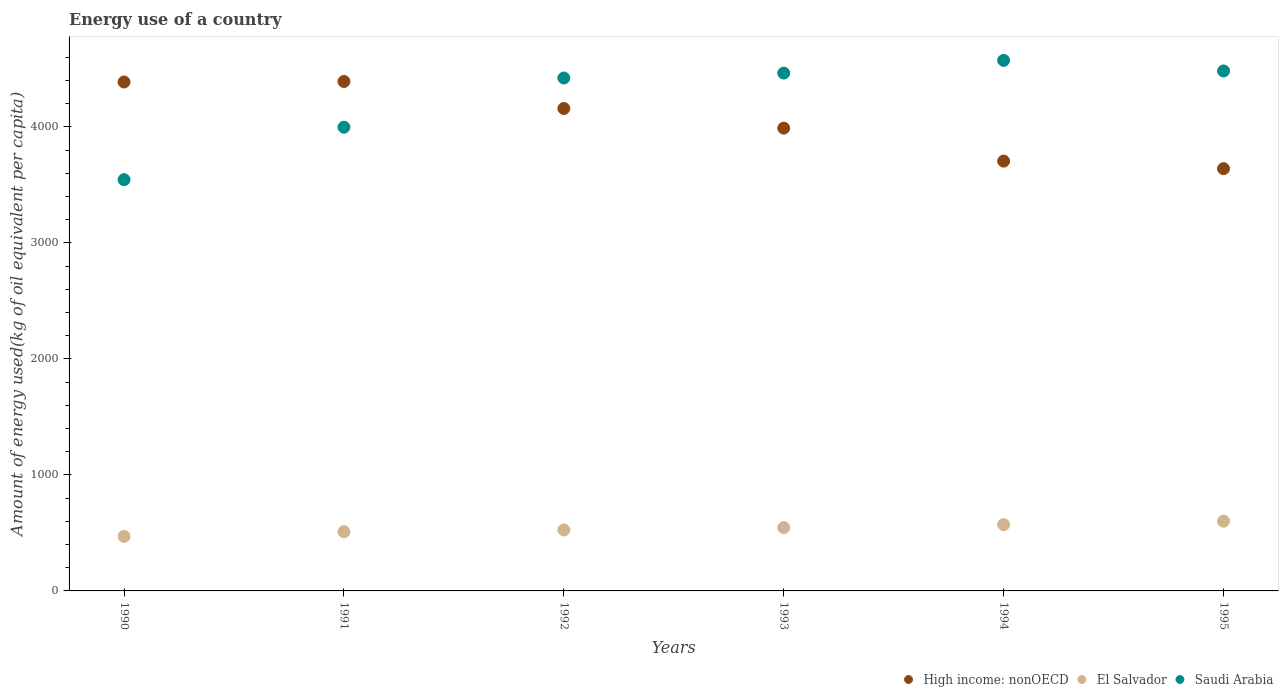How many different coloured dotlines are there?
Provide a succinct answer. 3. Is the number of dotlines equal to the number of legend labels?
Provide a succinct answer. Yes. What is the amount of energy used in in High income: nonOECD in 1991?
Your response must be concise. 4391.51. Across all years, what is the maximum amount of energy used in in High income: nonOECD?
Your response must be concise. 4391.51. Across all years, what is the minimum amount of energy used in in Saudi Arabia?
Ensure brevity in your answer.  3545.24. In which year was the amount of energy used in in Saudi Arabia maximum?
Provide a short and direct response. 1994. What is the total amount of energy used in in El Salvador in the graph?
Give a very brief answer. 3224.03. What is the difference between the amount of energy used in in El Salvador in 1990 and that in 1995?
Your response must be concise. -130.95. What is the difference between the amount of energy used in in High income: nonOECD in 1993 and the amount of energy used in in Saudi Arabia in 1992?
Keep it short and to the point. -432.37. What is the average amount of energy used in in High income: nonOECD per year?
Your response must be concise. 4045.3. In the year 1995, what is the difference between the amount of energy used in in El Salvador and amount of energy used in in Saudi Arabia?
Keep it short and to the point. -3881.29. What is the ratio of the amount of energy used in in Saudi Arabia in 1990 to that in 1993?
Give a very brief answer. 0.79. What is the difference between the highest and the second highest amount of energy used in in High income: nonOECD?
Keep it short and to the point. 4.27. What is the difference between the highest and the lowest amount of energy used in in El Salvador?
Your answer should be compact. 130.95. Is the sum of the amount of energy used in in High income: nonOECD in 1992 and 1995 greater than the maximum amount of energy used in in Saudi Arabia across all years?
Offer a terse response. Yes. Is it the case that in every year, the sum of the amount of energy used in in Saudi Arabia and amount of energy used in in High income: nonOECD  is greater than the amount of energy used in in El Salvador?
Keep it short and to the point. Yes. Does the amount of energy used in in High income: nonOECD monotonically increase over the years?
Provide a short and direct response. No. Is the amount of energy used in in El Salvador strictly less than the amount of energy used in in High income: nonOECD over the years?
Keep it short and to the point. Yes. How many years are there in the graph?
Offer a very short reply. 6. What is the difference between two consecutive major ticks on the Y-axis?
Provide a succinct answer. 1000. Does the graph contain grids?
Offer a very short reply. No. How many legend labels are there?
Give a very brief answer. 3. What is the title of the graph?
Offer a terse response. Energy use of a country. What is the label or title of the Y-axis?
Your response must be concise. Amount of energy used(kg of oil equivalent per capita). What is the Amount of energy used(kg of oil equivalent per capita) in High income: nonOECD in 1990?
Your response must be concise. 4387.24. What is the Amount of energy used(kg of oil equivalent per capita) of El Salvador in 1990?
Your response must be concise. 470.04. What is the Amount of energy used(kg of oil equivalent per capita) in Saudi Arabia in 1990?
Your answer should be compact. 3545.24. What is the Amount of energy used(kg of oil equivalent per capita) of High income: nonOECD in 1991?
Offer a very short reply. 4391.51. What is the Amount of energy used(kg of oil equivalent per capita) of El Salvador in 1991?
Ensure brevity in your answer.  510.06. What is the Amount of energy used(kg of oil equivalent per capita) in Saudi Arabia in 1991?
Ensure brevity in your answer.  3997.62. What is the Amount of energy used(kg of oil equivalent per capita) of High income: nonOECD in 1992?
Offer a very short reply. 4158.79. What is the Amount of energy used(kg of oil equivalent per capita) of El Salvador in 1992?
Offer a terse response. 525.45. What is the Amount of energy used(kg of oil equivalent per capita) in Saudi Arabia in 1992?
Provide a short and direct response. 4421.51. What is the Amount of energy used(kg of oil equivalent per capita) in High income: nonOECD in 1993?
Your response must be concise. 3989.13. What is the Amount of energy used(kg of oil equivalent per capita) of El Salvador in 1993?
Provide a succinct answer. 546.06. What is the Amount of energy used(kg of oil equivalent per capita) of Saudi Arabia in 1993?
Your answer should be very brief. 4463.81. What is the Amount of energy used(kg of oil equivalent per capita) of High income: nonOECD in 1994?
Your response must be concise. 3705.16. What is the Amount of energy used(kg of oil equivalent per capita) of El Salvador in 1994?
Make the answer very short. 571.42. What is the Amount of energy used(kg of oil equivalent per capita) of Saudi Arabia in 1994?
Make the answer very short. 4573.44. What is the Amount of energy used(kg of oil equivalent per capita) in High income: nonOECD in 1995?
Keep it short and to the point. 3639.98. What is the Amount of energy used(kg of oil equivalent per capita) of El Salvador in 1995?
Offer a terse response. 601. What is the Amount of energy used(kg of oil equivalent per capita) of Saudi Arabia in 1995?
Give a very brief answer. 4482.28. Across all years, what is the maximum Amount of energy used(kg of oil equivalent per capita) of High income: nonOECD?
Provide a short and direct response. 4391.51. Across all years, what is the maximum Amount of energy used(kg of oil equivalent per capita) in El Salvador?
Make the answer very short. 601. Across all years, what is the maximum Amount of energy used(kg of oil equivalent per capita) in Saudi Arabia?
Your answer should be very brief. 4573.44. Across all years, what is the minimum Amount of energy used(kg of oil equivalent per capita) of High income: nonOECD?
Your answer should be very brief. 3639.98. Across all years, what is the minimum Amount of energy used(kg of oil equivalent per capita) of El Salvador?
Ensure brevity in your answer.  470.04. Across all years, what is the minimum Amount of energy used(kg of oil equivalent per capita) of Saudi Arabia?
Provide a short and direct response. 3545.24. What is the total Amount of energy used(kg of oil equivalent per capita) in High income: nonOECD in the graph?
Offer a terse response. 2.43e+04. What is the total Amount of energy used(kg of oil equivalent per capita) in El Salvador in the graph?
Offer a very short reply. 3224.03. What is the total Amount of energy used(kg of oil equivalent per capita) of Saudi Arabia in the graph?
Ensure brevity in your answer.  2.55e+04. What is the difference between the Amount of energy used(kg of oil equivalent per capita) in High income: nonOECD in 1990 and that in 1991?
Keep it short and to the point. -4.27. What is the difference between the Amount of energy used(kg of oil equivalent per capita) in El Salvador in 1990 and that in 1991?
Your answer should be compact. -40.02. What is the difference between the Amount of energy used(kg of oil equivalent per capita) in Saudi Arabia in 1990 and that in 1991?
Keep it short and to the point. -452.37. What is the difference between the Amount of energy used(kg of oil equivalent per capita) of High income: nonOECD in 1990 and that in 1992?
Keep it short and to the point. 228.45. What is the difference between the Amount of energy used(kg of oil equivalent per capita) in El Salvador in 1990 and that in 1992?
Your answer should be compact. -55.41. What is the difference between the Amount of energy used(kg of oil equivalent per capita) in Saudi Arabia in 1990 and that in 1992?
Ensure brevity in your answer.  -876.27. What is the difference between the Amount of energy used(kg of oil equivalent per capita) in High income: nonOECD in 1990 and that in 1993?
Your response must be concise. 398.11. What is the difference between the Amount of energy used(kg of oil equivalent per capita) of El Salvador in 1990 and that in 1993?
Ensure brevity in your answer.  -76.01. What is the difference between the Amount of energy used(kg of oil equivalent per capita) in Saudi Arabia in 1990 and that in 1993?
Offer a terse response. -918.57. What is the difference between the Amount of energy used(kg of oil equivalent per capita) of High income: nonOECD in 1990 and that in 1994?
Your answer should be compact. 682.08. What is the difference between the Amount of energy used(kg of oil equivalent per capita) of El Salvador in 1990 and that in 1994?
Provide a succinct answer. -101.37. What is the difference between the Amount of energy used(kg of oil equivalent per capita) in Saudi Arabia in 1990 and that in 1994?
Offer a terse response. -1028.2. What is the difference between the Amount of energy used(kg of oil equivalent per capita) in High income: nonOECD in 1990 and that in 1995?
Provide a short and direct response. 747.26. What is the difference between the Amount of energy used(kg of oil equivalent per capita) in El Salvador in 1990 and that in 1995?
Your answer should be compact. -130.95. What is the difference between the Amount of energy used(kg of oil equivalent per capita) of Saudi Arabia in 1990 and that in 1995?
Make the answer very short. -937.04. What is the difference between the Amount of energy used(kg of oil equivalent per capita) of High income: nonOECD in 1991 and that in 1992?
Offer a terse response. 232.72. What is the difference between the Amount of energy used(kg of oil equivalent per capita) in El Salvador in 1991 and that in 1992?
Make the answer very short. -15.39. What is the difference between the Amount of energy used(kg of oil equivalent per capita) of Saudi Arabia in 1991 and that in 1992?
Provide a short and direct response. -423.89. What is the difference between the Amount of energy used(kg of oil equivalent per capita) in High income: nonOECD in 1991 and that in 1993?
Provide a succinct answer. 402.38. What is the difference between the Amount of energy used(kg of oil equivalent per capita) in El Salvador in 1991 and that in 1993?
Give a very brief answer. -35.99. What is the difference between the Amount of energy used(kg of oil equivalent per capita) in Saudi Arabia in 1991 and that in 1993?
Your answer should be very brief. -466.19. What is the difference between the Amount of energy used(kg of oil equivalent per capita) in High income: nonOECD in 1991 and that in 1994?
Your response must be concise. 686.35. What is the difference between the Amount of energy used(kg of oil equivalent per capita) in El Salvador in 1991 and that in 1994?
Give a very brief answer. -61.35. What is the difference between the Amount of energy used(kg of oil equivalent per capita) in Saudi Arabia in 1991 and that in 1994?
Your answer should be very brief. -575.83. What is the difference between the Amount of energy used(kg of oil equivalent per capita) in High income: nonOECD in 1991 and that in 1995?
Offer a very short reply. 751.53. What is the difference between the Amount of energy used(kg of oil equivalent per capita) of El Salvador in 1991 and that in 1995?
Give a very brief answer. -90.94. What is the difference between the Amount of energy used(kg of oil equivalent per capita) in Saudi Arabia in 1991 and that in 1995?
Give a very brief answer. -484.67. What is the difference between the Amount of energy used(kg of oil equivalent per capita) of High income: nonOECD in 1992 and that in 1993?
Ensure brevity in your answer.  169.66. What is the difference between the Amount of energy used(kg of oil equivalent per capita) of El Salvador in 1992 and that in 1993?
Keep it short and to the point. -20.6. What is the difference between the Amount of energy used(kg of oil equivalent per capita) in Saudi Arabia in 1992 and that in 1993?
Give a very brief answer. -42.3. What is the difference between the Amount of energy used(kg of oil equivalent per capita) in High income: nonOECD in 1992 and that in 1994?
Provide a succinct answer. 453.63. What is the difference between the Amount of energy used(kg of oil equivalent per capita) of El Salvador in 1992 and that in 1994?
Provide a succinct answer. -45.96. What is the difference between the Amount of energy used(kg of oil equivalent per capita) of Saudi Arabia in 1992 and that in 1994?
Keep it short and to the point. -151.94. What is the difference between the Amount of energy used(kg of oil equivalent per capita) of High income: nonOECD in 1992 and that in 1995?
Provide a succinct answer. 518.81. What is the difference between the Amount of energy used(kg of oil equivalent per capita) in El Salvador in 1992 and that in 1995?
Your response must be concise. -75.54. What is the difference between the Amount of energy used(kg of oil equivalent per capita) in Saudi Arabia in 1992 and that in 1995?
Your answer should be very brief. -60.78. What is the difference between the Amount of energy used(kg of oil equivalent per capita) of High income: nonOECD in 1993 and that in 1994?
Your answer should be compact. 283.97. What is the difference between the Amount of energy used(kg of oil equivalent per capita) of El Salvador in 1993 and that in 1994?
Make the answer very short. -25.36. What is the difference between the Amount of energy used(kg of oil equivalent per capita) in Saudi Arabia in 1993 and that in 1994?
Keep it short and to the point. -109.64. What is the difference between the Amount of energy used(kg of oil equivalent per capita) in High income: nonOECD in 1993 and that in 1995?
Keep it short and to the point. 349.15. What is the difference between the Amount of energy used(kg of oil equivalent per capita) of El Salvador in 1993 and that in 1995?
Provide a succinct answer. -54.94. What is the difference between the Amount of energy used(kg of oil equivalent per capita) in Saudi Arabia in 1993 and that in 1995?
Ensure brevity in your answer.  -18.48. What is the difference between the Amount of energy used(kg of oil equivalent per capita) in High income: nonOECD in 1994 and that in 1995?
Your response must be concise. 65.18. What is the difference between the Amount of energy used(kg of oil equivalent per capita) in El Salvador in 1994 and that in 1995?
Provide a succinct answer. -29.58. What is the difference between the Amount of energy used(kg of oil equivalent per capita) of Saudi Arabia in 1994 and that in 1995?
Your response must be concise. 91.16. What is the difference between the Amount of energy used(kg of oil equivalent per capita) of High income: nonOECD in 1990 and the Amount of energy used(kg of oil equivalent per capita) of El Salvador in 1991?
Make the answer very short. 3877.18. What is the difference between the Amount of energy used(kg of oil equivalent per capita) of High income: nonOECD in 1990 and the Amount of energy used(kg of oil equivalent per capita) of Saudi Arabia in 1991?
Keep it short and to the point. 389.62. What is the difference between the Amount of energy used(kg of oil equivalent per capita) in El Salvador in 1990 and the Amount of energy used(kg of oil equivalent per capita) in Saudi Arabia in 1991?
Ensure brevity in your answer.  -3527.57. What is the difference between the Amount of energy used(kg of oil equivalent per capita) in High income: nonOECD in 1990 and the Amount of energy used(kg of oil equivalent per capita) in El Salvador in 1992?
Offer a terse response. 3861.79. What is the difference between the Amount of energy used(kg of oil equivalent per capita) of High income: nonOECD in 1990 and the Amount of energy used(kg of oil equivalent per capita) of Saudi Arabia in 1992?
Your answer should be very brief. -34.27. What is the difference between the Amount of energy used(kg of oil equivalent per capita) of El Salvador in 1990 and the Amount of energy used(kg of oil equivalent per capita) of Saudi Arabia in 1992?
Your answer should be compact. -3951.46. What is the difference between the Amount of energy used(kg of oil equivalent per capita) of High income: nonOECD in 1990 and the Amount of energy used(kg of oil equivalent per capita) of El Salvador in 1993?
Your answer should be compact. 3841.18. What is the difference between the Amount of energy used(kg of oil equivalent per capita) of High income: nonOECD in 1990 and the Amount of energy used(kg of oil equivalent per capita) of Saudi Arabia in 1993?
Your response must be concise. -76.57. What is the difference between the Amount of energy used(kg of oil equivalent per capita) of El Salvador in 1990 and the Amount of energy used(kg of oil equivalent per capita) of Saudi Arabia in 1993?
Your answer should be very brief. -3993.76. What is the difference between the Amount of energy used(kg of oil equivalent per capita) of High income: nonOECD in 1990 and the Amount of energy used(kg of oil equivalent per capita) of El Salvador in 1994?
Offer a terse response. 3815.82. What is the difference between the Amount of energy used(kg of oil equivalent per capita) in High income: nonOECD in 1990 and the Amount of energy used(kg of oil equivalent per capita) in Saudi Arabia in 1994?
Make the answer very short. -186.2. What is the difference between the Amount of energy used(kg of oil equivalent per capita) in El Salvador in 1990 and the Amount of energy used(kg of oil equivalent per capita) in Saudi Arabia in 1994?
Keep it short and to the point. -4103.4. What is the difference between the Amount of energy used(kg of oil equivalent per capita) of High income: nonOECD in 1990 and the Amount of energy used(kg of oil equivalent per capita) of El Salvador in 1995?
Ensure brevity in your answer.  3786.24. What is the difference between the Amount of energy used(kg of oil equivalent per capita) in High income: nonOECD in 1990 and the Amount of energy used(kg of oil equivalent per capita) in Saudi Arabia in 1995?
Provide a short and direct response. -95.04. What is the difference between the Amount of energy used(kg of oil equivalent per capita) in El Salvador in 1990 and the Amount of energy used(kg of oil equivalent per capita) in Saudi Arabia in 1995?
Make the answer very short. -4012.24. What is the difference between the Amount of energy used(kg of oil equivalent per capita) in High income: nonOECD in 1991 and the Amount of energy used(kg of oil equivalent per capita) in El Salvador in 1992?
Your answer should be very brief. 3866.06. What is the difference between the Amount of energy used(kg of oil equivalent per capita) in High income: nonOECD in 1991 and the Amount of energy used(kg of oil equivalent per capita) in Saudi Arabia in 1992?
Offer a terse response. -30. What is the difference between the Amount of energy used(kg of oil equivalent per capita) of El Salvador in 1991 and the Amount of energy used(kg of oil equivalent per capita) of Saudi Arabia in 1992?
Provide a succinct answer. -3911.45. What is the difference between the Amount of energy used(kg of oil equivalent per capita) in High income: nonOECD in 1991 and the Amount of energy used(kg of oil equivalent per capita) in El Salvador in 1993?
Your answer should be compact. 3845.45. What is the difference between the Amount of energy used(kg of oil equivalent per capita) of High income: nonOECD in 1991 and the Amount of energy used(kg of oil equivalent per capita) of Saudi Arabia in 1993?
Keep it short and to the point. -72.3. What is the difference between the Amount of energy used(kg of oil equivalent per capita) of El Salvador in 1991 and the Amount of energy used(kg of oil equivalent per capita) of Saudi Arabia in 1993?
Your answer should be compact. -3953.75. What is the difference between the Amount of energy used(kg of oil equivalent per capita) of High income: nonOECD in 1991 and the Amount of energy used(kg of oil equivalent per capita) of El Salvador in 1994?
Your answer should be very brief. 3820.09. What is the difference between the Amount of energy used(kg of oil equivalent per capita) of High income: nonOECD in 1991 and the Amount of energy used(kg of oil equivalent per capita) of Saudi Arabia in 1994?
Ensure brevity in your answer.  -181.93. What is the difference between the Amount of energy used(kg of oil equivalent per capita) in El Salvador in 1991 and the Amount of energy used(kg of oil equivalent per capita) in Saudi Arabia in 1994?
Your answer should be very brief. -4063.38. What is the difference between the Amount of energy used(kg of oil equivalent per capita) in High income: nonOECD in 1991 and the Amount of energy used(kg of oil equivalent per capita) in El Salvador in 1995?
Your response must be concise. 3790.51. What is the difference between the Amount of energy used(kg of oil equivalent per capita) in High income: nonOECD in 1991 and the Amount of energy used(kg of oil equivalent per capita) in Saudi Arabia in 1995?
Keep it short and to the point. -90.77. What is the difference between the Amount of energy used(kg of oil equivalent per capita) of El Salvador in 1991 and the Amount of energy used(kg of oil equivalent per capita) of Saudi Arabia in 1995?
Keep it short and to the point. -3972.22. What is the difference between the Amount of energy used(kg of oil equivalent per capita) of High income: nonOECD in 1992 and the Amount of energy used(kg of oil equivalent per capita) of El Salvador in 1993?
Make the answer very short. 3612.73. What is the difference between the Amount of energy used(kg of oil equivalent per capita) in High income: nonOECD in 1992 and the Amount of energy used(kg of oil equivalent per capita) in Saudi Arabia in 1993?
Provide a short and direct response. -305.02. What is the difference between the Amount of energy used(kg of oil equivalent per capita) in El Salvador in 1992 and the Amount of energy used(kg of oil equivalent per capita) in Saudi Arabia in 1993?
Offer a terse response. -3938.35. What is the difference between the Amount of energy used(kg of oil equivalent per capita) in High income: nonOECD in 1992 and the Amount of energy used(kg of oil equivalent per capita) in El Salvador in 1994?
Your answer should be very brief. 3587.37. What is the difference between the Amount of energy used(kg of oil equivalent per capita) of High income: nonOECD in 1992 and the Amount of energy used(kg of oil equivalent per capita) of Saudi Arabia in 1994?
Offer a terse response. -414.65. What is the difference between the Amount of energy used(kg of oil equivalent per capita) of El Salvador in 1992 and the Amount of energy used(kg of oil equivalent per capita) of Saudi Arabia in 1994?
Your answer should be compact. -4047.99. What is the difference between the Amount of energy used(kg of oil equivalent per capita) in High income: nonOECD in 1992 and the Amount of energy used(kg of oil equivalent per capita) in El Salvador in 1995?
Give a very brief answer. 3557.79. What is the difference between the Amount of energy used(kg of oil equivalent per capita) of High income: nonOECD in 1992 and the Amount of energy used(kg of oil equivalent per capita) of Saudi Arabia in 1995?
Make the answer very short. -323.49. What is the difference between the Amount of energy used(kg of oil equivalent per capita) of El Salvador in 1992 and the Amount of energy used(kg of oil equivalent per capita) of Saudi Arabia in 1995?
Make the answer very short. -3956.83. What is the difference between the Amount of energy used(kg of oil equivalent per capita) in High income: nonOECD in 1993 and the Amount of energy used(kg of oil equivalent per capita) in El Salvador in 1994?
Provide a short and direct response. 3417.72. What is the difference between the Amount of energy used(kg of oil equivalent per capita) in High income: nonOECD in 1993 and the Amount of energy used(kg of oil equivalent per capita) in Saudi Arabia in 1994?
Ensure brevity in your answer.  -584.31. What is the difference between the Amount of energy used(kg of oil equivalent per capita) in El Salvador in 1993 and the Amount of energy used(kg of oil equivalent per capita) in Saudi Arabia in 1994?
Offer a terse response. -4027.39. What is the difference between the Amount of energy used(kg of oil equivalent per capita) of High income: nonOECD in 1993 and the Amount of energy used(kg of oil equivalent per capita) of El Salvador in 1995?
Offer a very short reply. 3388.14. What is the difference between the Amount of energy used(kg of oil equivalent per capita) in High income: nonOECD in 1993 and the Amount of energy used(kg of oil equivalent per capita) in Saudi Arabia in 1995?
Offer a very short reply. -493.15. What is the difference between the Amount of energy used(kg of oil equivalent per capita) of El Salvador in 1993 and the Amount of energy used(kg of oil equivalent per capita) of Saudi Arabia in 1995?
Ensure brevity in your answer.  -3936.23. What is the difference between the Amount of energy used(kg of oil equivalent per capita) in High income: nonOECD in 1994 and the Amount of energy used(kg of oil equivalent per capita) in El Salvador in 1995?
Provide a short and direct response. 3104.16. What is the difference between the Amount of energy used(kg of oil equivalent per capita) in High income: nonOECD in 1994 and the Amount of energy used(kg of oil equivalent per capita) in Saudi Arabia in 1995?
Offer a very short reply. -777.12. What is the difference between the Amount of energy used(kg of oil equivalent per capita) of El Salvador in 1994 and the Amount of energy used(kg of oil equivalent per capita) of Saudi Arabia in 1995?
Offer a terse response. -3910.87. What is the average Amount of energy used(kg of oil equivalent per capita) of High income: nonOECD per year?
Your response must be concise. 4045.3. What is the average Amount of energy used(kg of oil equivalent per capita) in El Salvador per year?
Keep it short and to the point. 537.34. What is the average Amount of energy used(kg of oil equivalent per capita) in Saudi Arabia per year?
Offer a terse response. 4247.32. In the year 1990, what is the difference between the Amount of energy used(kg of oil equivalent per capita) in High income: nonOECD and Amount of energy used(kg of oil equivalent per capita) in El Salvador?
Your answer should be compact. 3917.2. In the year 1990, what is the difference between the Amount of energy used(kg of oil equivalent per capita) of High income: nonOECD and Amount of energy used(kg of oil equivalent per capita) of Saudi Arabia?
Provide a short and direct response. 842. In the year 1990, what is the difference between the Amount of energy used(kg of oil equivalent per capita) in El Salvador and Amount of energy used(kg of oil equivalent per capita) in Saudi Arabia?
Your answer should be compact. -3075.2. In the year 1991, what is the difference between the Amount of energy used(kg of oil equivalent per capita) of High income: nonOECD and Amount of energy used(kg of oil equivalent per capita) of El Salvador?
Keep it short and to the point. 3881.45. In the year 1991, what is the difference between the Amount of energy used(kg of oil equivalent per capita) in High income: nonOECD and Amount of energy used(kg of oil equivalent per capita) in Saudi Arabia?
Ensure brevity in your answer.  393.89. In the year 1991, what is the difference between the Amount of energy used(kg of oil equivalent per capita) in El Salvador and Amount of energy used(kg of oil equivalent per capita) in Saudi Arabia?
Give a very brief answer. -3487.55. In the year 1992, what is the difference between the Amount of energy used(kg of oil equivalent per capita) of High income: nonOECD and Amount of energy used(kg of oil equivalent per capita) of El Salvador?
Keep it short and to the point. 3633.34. In the year 1992, what is the difference between the Amount of energy used(kg of oil equivalent per capita) in High income: nonOECD and Amount of energy used(kg of oil equivalent per capita) in Saudi Arabia?
Make the answer very short. -262.72. In the year 1992, what is the difference between the Amount of energy used(kg of oil equivalent per capita) in El Salvador and Amount of energy used(kg of oil equivalent per capita) in Saudi Arabia?
Offer a terse response. -3896.05. In the year 1993, what is the difference between the Amount of energy used(kg of oil equivalent per capita) of High income: nonOECD and Amount of energy used(kg of oil equivalent per capita) of El Salvador?
Make the answer very short. 3443.08. In the year 1993, what is the difference between the Amount of energy used(kg of oil equivalent per capita) in High income: nonOECD and Amount of energy used(kg of oil equivalent per capita) in Saudi Arabia?
Ensure brevity in your answer.  -474.67. In the year 1993, what is the difference between the Amount of energy used(kg of oil equivalent per capita) of El Salvador and Amount of energy used(kg of oil equivalent per capita) of Saudi Arabia?
Your response must be concise. -3917.75. In the year 1994, what is the difference between the Amount of energy used(kg of oil equivalent per capita) of High income: nonOECD and Amount of energy used(kg of oil equivalent per capita) of El Salvador?
Provide a succinct answer. 3133.75. In the year 1994, what is the difference between the Amount of energy used(kg of oil equivalent per capita) in High income: nonOECD and Amount of energy used(kg of oil equivalent per capita) in Saudi Arabia?
Keep it short and to the point. -868.28. In the year 1994, what is the difference between the Amount of energy used(kg of oil equivalent per capita) of El Salvador and Amount of energy used(kg of oil equivalent per capita) of Saudi Arabia?
Ensure brevity in your answer.  -4002.03. In the year 1995, what is the difference between the Amount of energy used(kg of oil equivalent per capita) of High income: nonOECD and Amount of energy used(kg of oil equivalent per capita) of El Salvador?
Your answer should be compact. 3038.99. In the year 1995, what is the difference between the Amount of energy used(kg of oil equivalent per capita) of High income: nonOECD and Amount of energy used(kg of oil equivalent per capita) of Saudi Arabia?
Your answer should be compact. -842.3. In the year 1995, what is the difference between the Amount of energy used(kg of oil equivalent per capita) of El Salvador and Amount of energy used(kg of oil equivalent per capita) of Saudi Arabia?
Your response must be concise. -3881.29. What is the ratio of the Amount of energy used(kg of oil equivalent per capita) in High income: nonOECD in 1990 to that in 1991?
Your answer should be very brief. 1. What is the ratio of the Amount of energy used(kg of oil equivalent per capita) in El Salvador in 1990 to that in 1991?
Offer a very short reply. 0.92. What is the ratio of the Amount of energy used(kg of oil equivalent per capita) of Saudi Arabia in 1990 to that in 1991?
Your response must be concise. 0.89. What is the ratio of the Amount of energy used(kg of oil equivalent per capita) of High income: nonOECD in 1990 to that in 1992?
Your answer should be compact. 1.05. What is the ratio of the Amount of energy used(kg of oil equivalent per capita) of El Salvador in 1990 to that in 1992?
Ensure brevity in your answer.  0.89. What is the ratio of the Amount of energy used(kg of oil equivalent per capita) of Saudi Arabia in 1990 to that in 1992?
Ensure brevity in your answer.  0.8. What is the ratio of the Amount of energy used(kg of oil equivalent per capita) of High income: nonOECD in 1990 to that in 1993?
Give a very brief answer. 1.1. What is the ratio of the Amount of energy used(kg of oil equivalent per capita) in El Salvador in 1990 to that in 1993?
Provide a short and direct response. 0.86. What is the ratio of the Amount of energy used(kg of oil equivalent per capita) of Saudi Arabia in 1990 to that in 1993?
Give a very brief answer. 0.79. What is the ratio of the Amount of energy used(kg of oil equivalent per capita) in High income: nonOECD in 1990 to that in 1994?
Your answer should be compact. 1.18. What is the ratio of the Amount of energy used(kg of oil equivalent per capita) of El Salvador in 1990 to that in 1994?
Provide a succinct answer. 0.82. What is the ratio of the Amount of energy used(kg of oil equivalent per capita) of Saudi Arabia in 1990 to that in 1994?
Provide a short and direct response. 0.78. What is the ratio of the Amount of energy used(kg of oil equivalent per capita) in High income: nonOECD in 1990 to that in 1995?
Your answer should be very brief. 1.21. What is the ratio of the Amount of energy used(kg of oil equivalent per capita) in El Salvador in 1990 to that in 1995?
Keep it short and to the point. 0.78. What is the ratio of the Amount of energy used(kg of oil equivalent per capita) in Saudi Arabia in 1990 to that in 1995?
Offer a very short reply. 0.79. What is the ratio of the Amount of energy used(kg of oil equivalent per capita) in High income: nonOECD in 1991 to that in 1992?
Provide a succinct answer. 1.06. What is the ratio of the Amount of energy used(kg of oil equivalent per capita) of El Salvador in 1991 to that in 1992?
Your answer should be very brief. 0.97. What is the ratio of the Amount of energy used(kg of oil equivalent per capita) of Saudi Arabia in 1991 to that in 1992?
Keep it short and to the point. 0.9. What is the ratio of the Amount of energy used(kg of oil equivalent per capita) of High income: nonOECD in 1991 to that in 1993?
Your answer should be compact. 1.1. What is the ratio of the Amount of energy used(kg of oil equivalent per capita) in El Salvador in 1991 to that in 1993?
Provide a succinct answer. 0.93. What is the ratio of the Amount of energy used(kg of oil equivalent per capita) of Saudi Arabia in 1991 to that in 1993?
Ensure brevity in your answer.  0.9. What is the ratio of the Amount of energy used(kg of oil equivalent per capita) in High income: nonOECD in 1991 to that in 1994?
Ensure brevity in your answer.  1.19. What is the ratio of the Amount of energy used(kg of oil equivalent per capita) of El Salvador in 1991 to that in 1994?
Keep it short and to the point. 0.89. What is the ratio of the Amount of energy used(kg of oil equivalent per capita) of Saudi Arabia in 1991 to that in 1994?
Provide a short and direct response. 0.87. What is the ratio of the Amount of energy used(kg of oil equivalent per capita) in High income: nonOECD in 1991 to that in 1995?
Offer a very short reply. 1.21. What is the ratio of the Amount of energy used(kg of oil equivalent per capita) of El Salvador in 1991 to that in 1995?
Offer a very short reply. 0.85. What is the ratio of the Amount of energy used(kg of oil equivalent per capita) in Saudi Arabia in 1991 to that in 1995?
Your answer should be compact. 0.89. What is the ratio of the Amount of energy used(kg of oil equivalent per capita) of High income: nonOECD in 1992 to that in 1993?
Give a very brief answer. 1.04. What is the ratio of the Amount of energy used(kg of oil equivalent per capita) in El Salvador in 1992 to that in 1993?
Ensure brevity in your answer.  0.96. What is the ratio of the Amount of energy used(kg of oil equivalent per capita) in High income: nonOECD in 1992 to that in 1994?
Provide a succinct answer. 1.12. What is the ratio of the Amount of energy used(kg of oil equivalent per capita) of El Salvador in 1992 to that in 1994?
Your answer should be compact. 0.92. What is the ratio of the Amount of energy used(kg of oil equivalent per capita) in Saudi Arabia in 1992 to that in 1994?
Give a very brief answer. 0.97. What is the ratio of the Amount of energy used(kg of oil equivalent per capita) in High income: nonOECD in 1992 to that in 1995?
Your answer should be very brief. 1.14. What is the ratio of the Amount of energy used(kg of oil equivalent per capita) in El Salvador in 1992 to that in 1995?
Your answer should be very brief. 0.87. What is the ratio of the Amount of energy used(kg of oil equivalent per capita) in Saudi Arabia in 1992 to that in 1995?
Your answer should be very brief. 0.99. What is the ratio of the Amount of energy used(kg of oil equivalent per capita) in High income: nonOECD in 1993 to that in 1994?
Ensure brevity in your answer.  1.08. What is the ratio of the Amount of energy used(kg of oil equivalent per capita) in El Salvador in 1993 to that in 1994?
Your answer should be compact. 0.96. What is the ratio of the Amount of energy used(kg of oil equivalent per capita) in High income: nonOECD in 1993 to that in 1995?
Keep it short and to the point. 1.1. What is the ratio of the Amount of energy used(kg of oil equivalent per capita) of El Salvador in 1993 to that in 1995?
Ensure brevity in your answer.  0.91. What is the ratio of the Amount of energy used(kg of oil equivalent per capita) of High income: nonOECD in 1994 to that in 1995?
Your answer should be very brief. 1.02. What is the ratio of the Amount of energy used(kg of oil equivalent per capita) of El Salvador in 1994 to that in 1995?
Your answer should be compact. 0.95. What is the ratio of the Amount of energy used(kg of oil equivalent per capita) in Saudi Arabia in 1994 to that in 1995?
Offer a very short reply. 1.02. What is the difference between the highest and the second highest Amount of energy used(kg of oil equivalent per capita) of High income: nonOECD?
Your answer should be very brief. 4.27. What is the difference between the highest and the second highest Amount of energy used(kg of oil equivalent per capita) of El Salvador?
Ensure brevity in your answer.  29.58. What is the difference between the highest and the second highest Amount of energy used(kg of oil equivalent per capita) of Saudi Arabia?
Make the answer very short. 91.16. What is the difference between the highest and the lowest Amount of energy used(kg of oil equivalent per capita) in High income: nonOECD?
Make the answer very short. 751.53. What is the difference between the highest and the lowest Amount of energy used(kg of oil equivalent per capita) in El Salvador?
Your response must be concise. 130.95. What is the difference between the highest and the lowest Amount of energy used(kg of oil equivalent per capita) in Saudi Arabia?
Keep it short and to the point. 1028.2. 